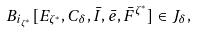<formula> <loc_0><loc_0><loc_500><loc_500>B _ { i _ { \zeta ^ { * } } } [ E _ { \zeta ^ { * } } , C _ { \delta } , \bar { I } , \bar { e } , \bar { F } ^ { \zeta ^ { * } } ] \in J _ { \delta } ,</formula> 